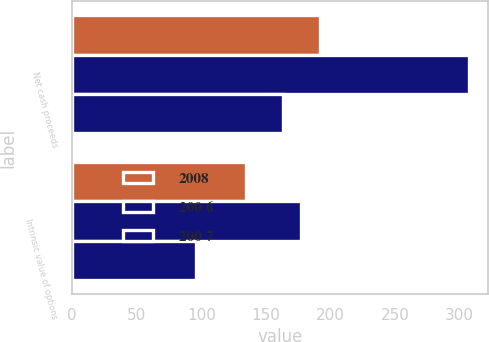Convert chart. <chart><loc_0><loc_0><loc_500><loc_500><stacked_bar_chart><ecel><fcel>Net cash proceeds<fcel>Intrinsic value of options<nl><fcel>2008<fcel>192<fcel>134.4<nl><fcel>200 6<fcel>307<fcel>177.3<nl><fcel>200 7<fcel>163.2<fcel>95.7<nl></chart> 